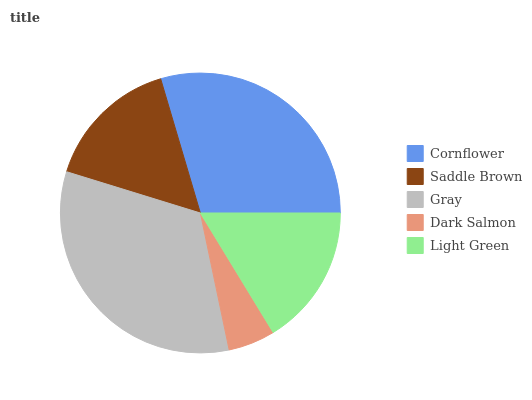Is Dark Salmon the minimum?
Answer yes or no. Yes. Is Gray the maximum?
Answer yes or no. Yes. Is Saddle Brown the minimum?
Answer yes or no. No. Is Saddle Brown the maximum?
Answer yes or no. No. Is Cornflower greater than Saddle Brown?
Answer yes or no. Yes. Is Saddle Brown less than Cornflower?
Answer yes or no. Yes. Is Saddle Brown greater than Cornflower?
Answer yes or no. No. Is Cornflower less than Saddle Brown?
Answer yes or no. No. Is Light Green the high median?
Answer yes or no. Yes. Is Light Green the low median?
Answer yes or no. Yes. Is Dark Salmon the high median?
Answer yes or no. No. Is Gray the low median?
Answer yes or no. No. 